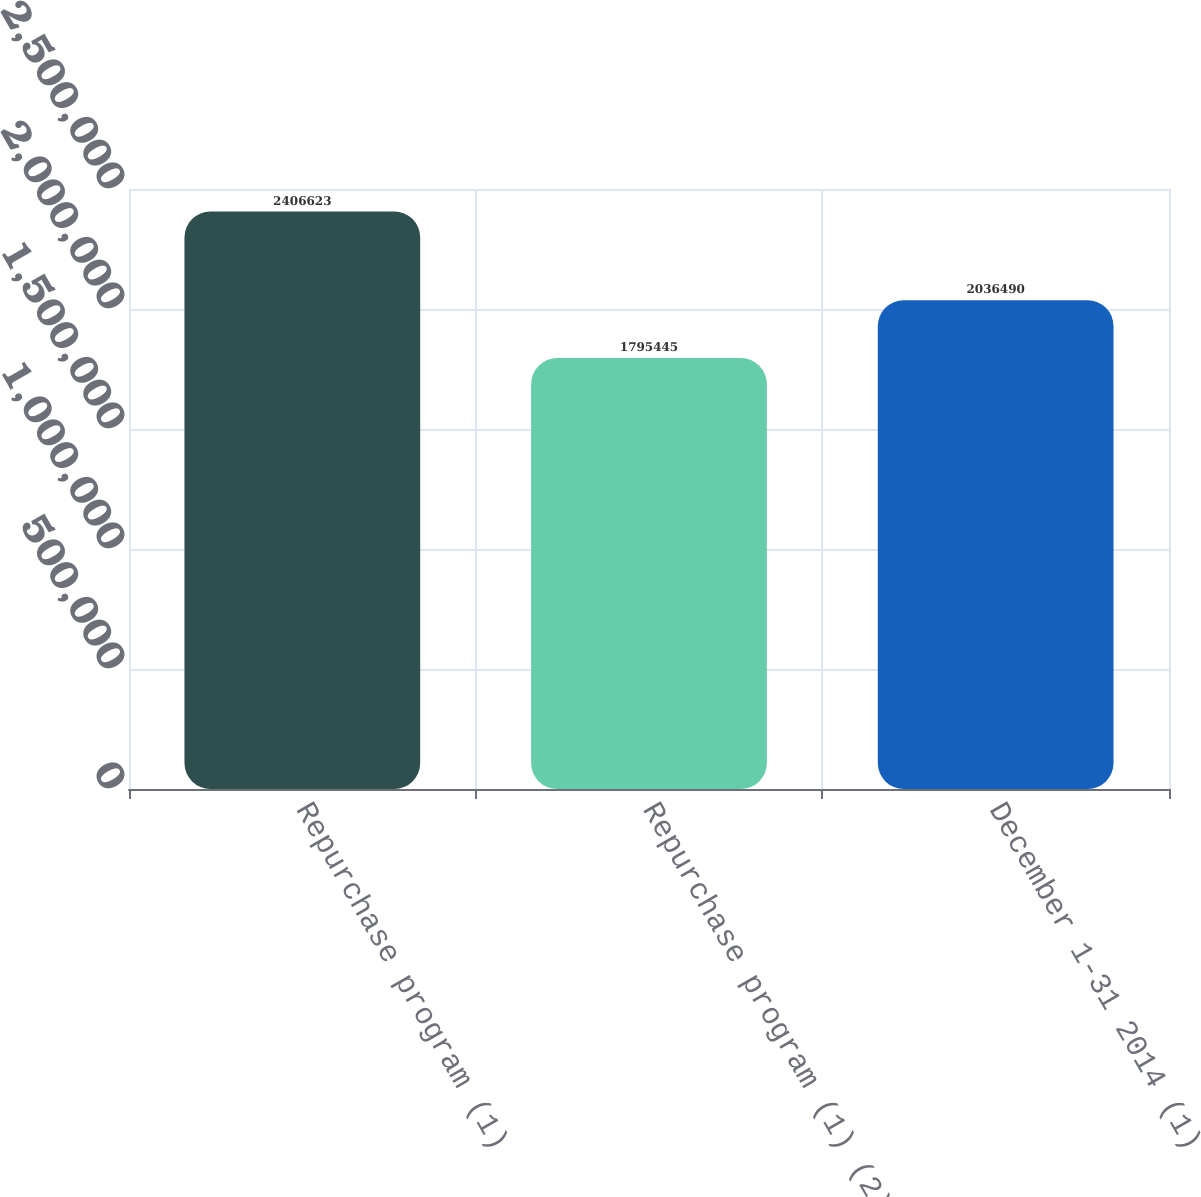Convert chart to OTSL. <chart><loc_0><loc_0><loc_500><loc_500><bar_chart><fcel>Repurchase program (1)<fcel>Repurchase program (1) (2)<fcel>December 1-31 2014 (1)<nl><fcel>2.40662e+06<fcel>1.79544e+06<fcel>2.03649e+06<nl></chart> 